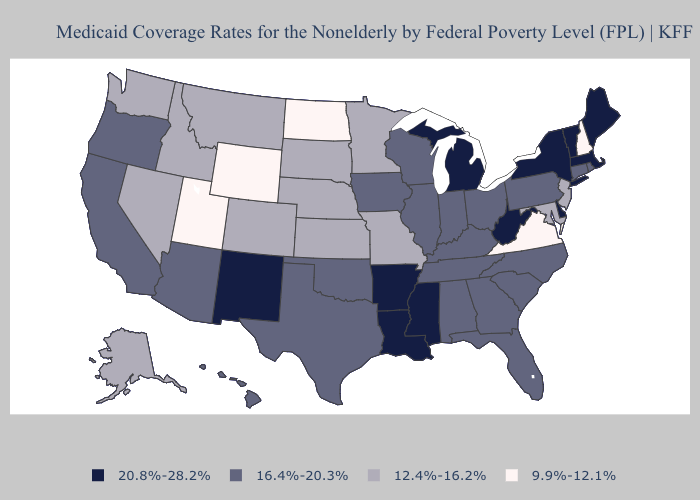Does Oregon have a higher value than Virginia?
Keep it brief. Yes. What is the lowest value in the USA?
Answer briefly. 9.9%-12.1%. What is the highest value in the MidWest ?
Answer briefly. 20.8%-28.2%. Does Vermont have the lowest value in the USA?
Give a very brief answer. No. Name the states that have a value in the range 9.9%-12.1%?
Short answer required. New Hampshire, North Dakota, Utah, Virginia, Wyoming. What is the value of California?
Answer briefly. 16.4%-20.3%. Name the states that have a value in the range 9.9%-12.1%?
Short answer required. New Hampshire, North Dakota, Utah, Virginia, Wyoming. What is the value of Colorado?
Keep it brief. 12.4%-16.2%. Name the states that have a value in the range 9.9%-12.1%?
Short answer required. New Hampshire, North Dakota, Utah, Virginia, Wyoming. Does Arizona have a lower value than Mississippi?
Short answer required. Yes. Does Iowa have the same value as Alaska?
Quick response, please. No. What is the value of Utah?
Write a very short answer. 9.9%-12.1%. Name the states that have a value in the range 20.8%-28.2%?
Be succinct. Arkansas, Delaware, Louisiana, Maine, Massachusetts, Michigan, Mississippi, New Mexico, New York, Vermont, West Virginia. Does Arkansas have a higher value than Louisiana?
Be succinct. No. 